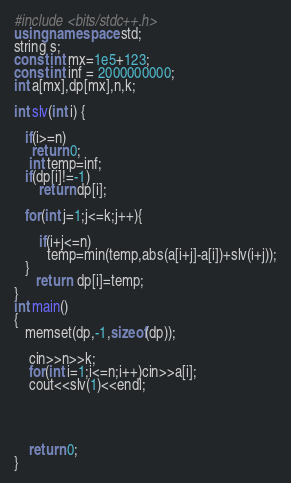<code> <loc_0><loc_0><loc_500><loc_500><_C++_>#include <bits/stdc++.h>
using namespace std;
string s;
const int mx=1e5+123;
const int inf = 2000000000;
int a[mx],dp[mx],n,k;

int slv(int i) {

   if(i>=n)
     return 0;
    int temp=inf;
   if(dp[i]!=-1)
       return dp[i];

   for(int j=1;j<=k;j++){

       if(i+j<=n)
         temp=min(temp,abs(a[i+j]-a[i])+slv(i+j));
   }
      return  dp[i]=temp;
}
int main()
{
   memset(dp,-1,sizeof(dp));

    cin>>n>>k;
    for(int i=1;i<=n;i++)cin>>a[i];
    cout<<slv(1)<<endl;




    return 0;
}</code> 